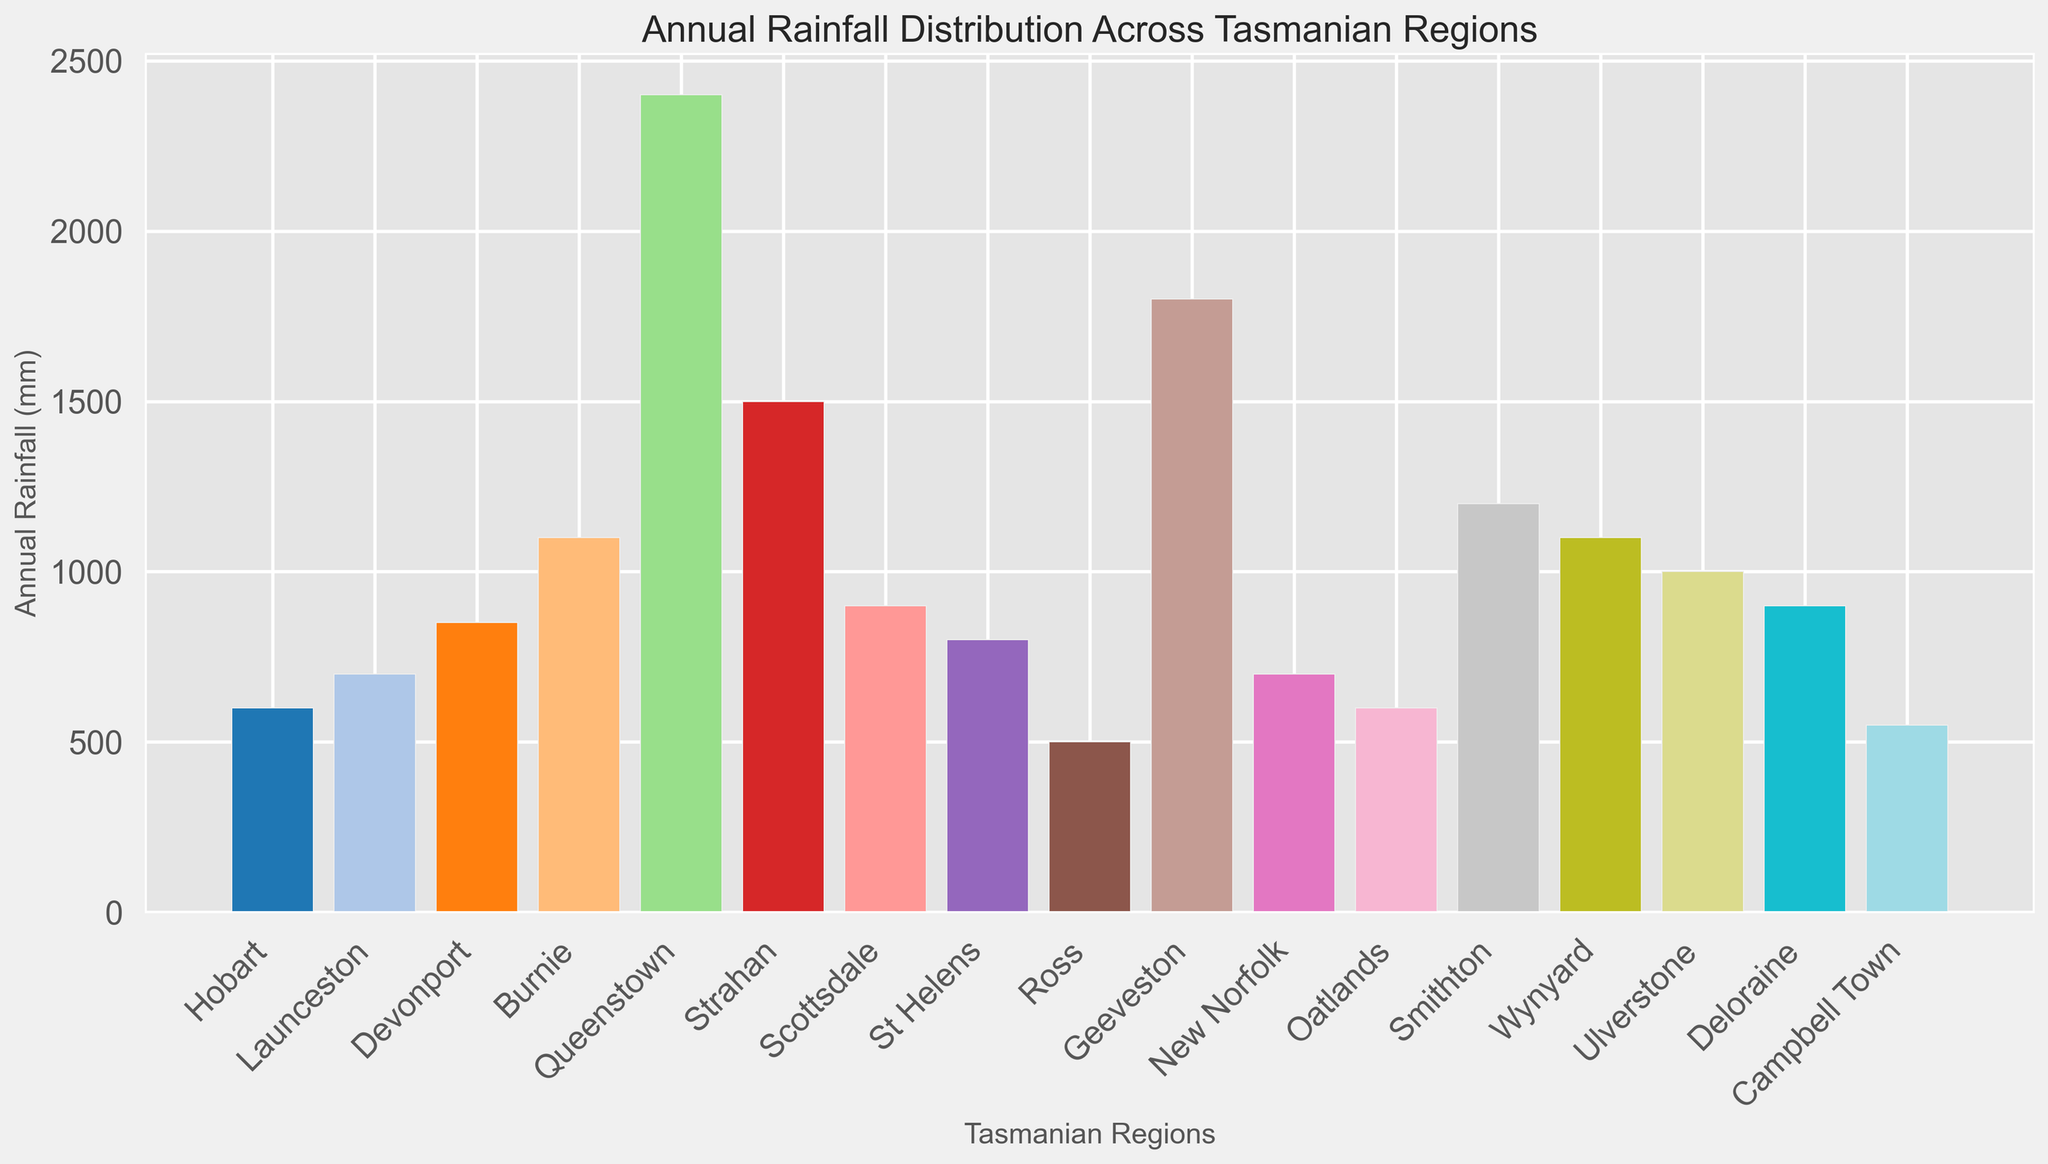What region has the highest annual rainfall? The tallest bar in the chart represents the highest annual rainfall. Queenstown has the highest bar indicating it has the highest annual rainfall.
Answer: Queenstown Which two regions have the same annual rainfall? By observing the heights of the bars and their labels, Burnie and Wynyard have bars of the same height, indicating the same annual rainfall.
Answer: Burnie and Wynyard What is the difference in annual rainfall between the region with the highest rainfall and the one with the lowest? Queenstown has the highest rainfall at 2400 mm, and Ross has the lowest at 500 mm. The difference is calculated as 2400 - 500.
Answer: 1900 mm Which region has nearly twice the annual rainfall of Hobart? Hobart has 600 mm of annual rainfall. Geeveston has 1800 mm, which is three times Hobart's values, so this is not correct. The nearest region with approximately twice the amount of 600 mm is Scottsdale with 900 mm.
Answer: Scottsdale How many regions have annual rainfall greater than 1000 mm? By visually counting the bars above the 1000 mm mark, Queenstown, Geeveston, Strahan, Smithton, Burnie, and Wynyard exceed 1000 mm.
Answer: 6 regions What is the median annual rainfall across all regions? First, list all rainfall values in ascending order (500, 550, 600, 600, 700, 700, 800, 850, 900, 900, 1000, 1100, 1100, 1200, 1500, 1800, 2400). The median is the middle value in the ordered list. For 17 regions, the middle value is the 9th value.
Answer: 900 mm Which region receives slightly more rainfall than St Helens? St Helens has 800 mm annual rainfall. The region with slightly more rainfall than St Helens is Devonport with 850 mm.
Answer: Devonport If you average the annual rainfall of the regions Hobart, Launceston, and Devonport, what is the result? Sum the rainfall values for Hobart (600 mm), Launceston (700 mm), and Devonport (850 mm), then divide by 3. (600 + 700 + 850)/3.
Answer: 717 mm Among the regions with annual rainfall less than 700 mm, which one has the highest rainfall? Identifying the regions with bars below the 700 mm mark, namely Hobart (600 mm), Ross (500 mm), Oatlands (600 mm), and Campbell Town (550 mm) and compare their values.
Answer: Hobart How many regions have annual rainfall values depicted by shades of blue in the chart? Upon examining the bar colors, shades of blue are seen in areas with lighter to deeper blue bars. This color range visually appears for four distinct bars.
Answer: 4 regions 